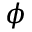Convert formula to latex. <formula><loc_0><loc_0><loc_500><loc_500>\phi</formula> 